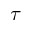<formula> <loc_0><loc_0><loc_500><loc_500>\tau</formula> 